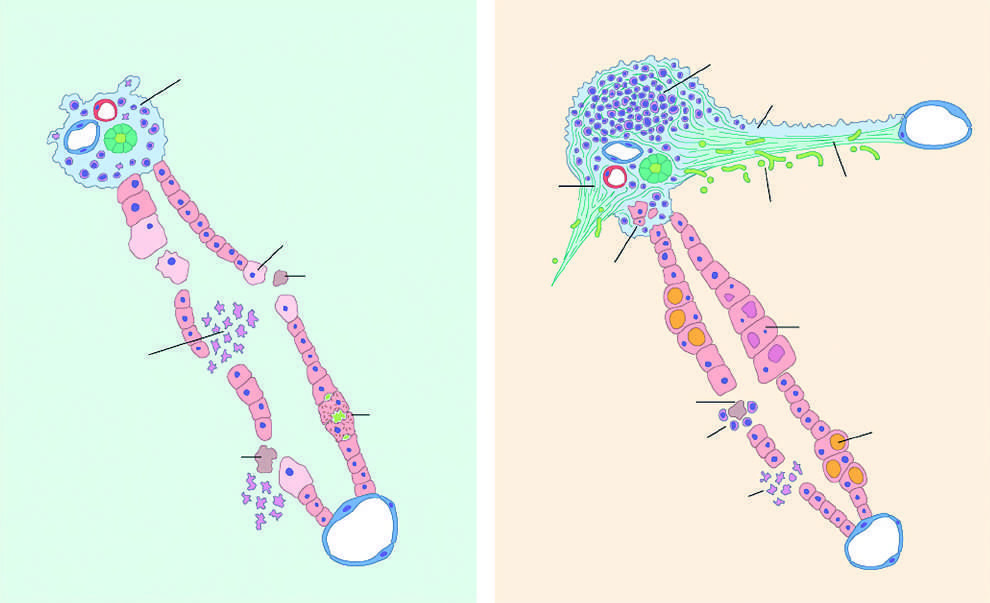what are dense and prominent?
Answer the question using a single word or phrase. Portal infiltrates 